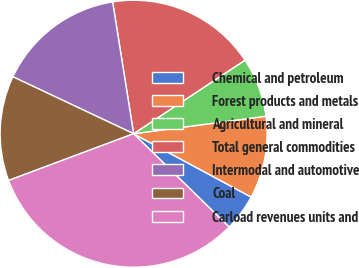<chart> <loc_0><loc_0><loc_500><loc_500><pie_chart><fcel>Chemical and petroleum<fcel>Forest products and metals<fcel>Agricultural and mineral<fcel>Total general commodities<fcel>Intermodal and automotive<fcel>Coal<fcel>Carload revenues units and<nl><fcel>4.45%<fcel>9.96%<fcel>7.2%<fcel>18.22%<fcel>15.47%<fcel>12.71%<fcel>31.99%<nl></chart> 